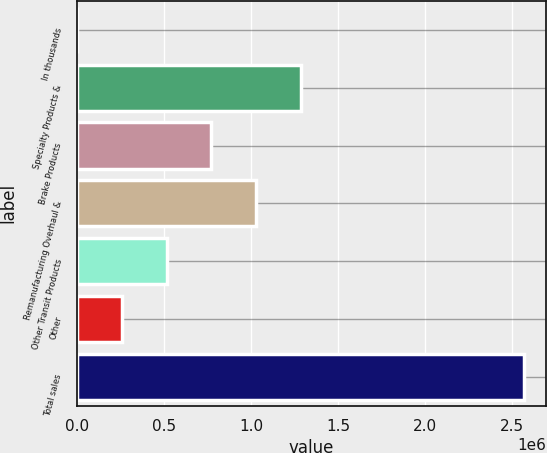<chart> <loc_0><loc_0><loc_500><loc_500><bar_chart><fcel>In thousands<fcel>Specialty Products &<fcel>Brake Products<fcel>Remanufacturing Overhaul &<fcel>Other Transit Products<fcel>Other<fcel>Total sales<nl><fcel>2013<fcel>1.2842e+06<fcel>771327<fcel>1.02776e+06<fcel>514889<fcel>258451<fcel>2.56639e+06<nl></chart> 